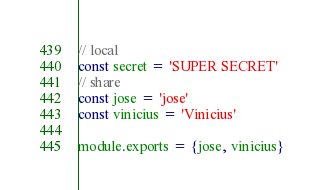<code> <loc_0><loc_0><loc_500><loc_500><_JavaScript_>// local
const secret = 'SUPER SECRET'
// share
const jose = 'jose'
const vinicius = 'Vinicius'

module.exports = {jose, vinicius}
</code> 